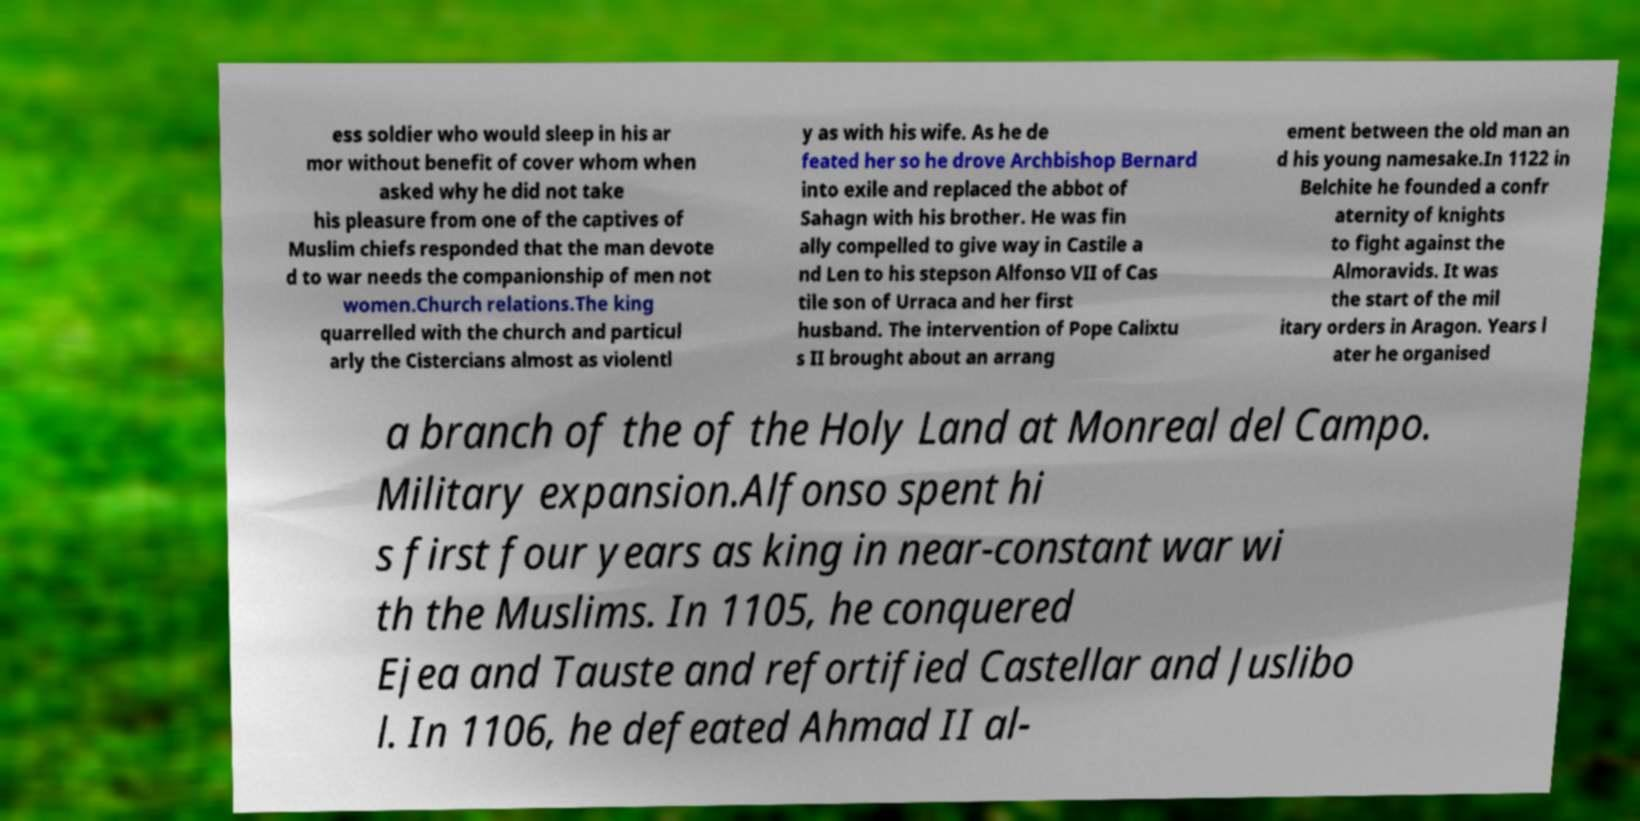I need the written content from this picture converted into text. Can you do that? ess soldier who would sleep in his ar mor without benefit of cover whom when asked why he did not take his pleasure from one of the captives of Muslim chiefs responded that the man devote d to war needs the companionship of men not women.Church relations.The king quarrelled with the church and particul arly the Cistercians almost as violentl y as with his wife. As he de feated her so he drove Archbishop Bernard into exile and replaced the abbot of Sahagn with his brother. He was fin ally compelled to give way in Castile a nd Len to his stepson Alfonso VII of Cas tile son of Urraca and her first husband. The intervention of Pope Calixtu s II brought about an arrang ement between the old man an d his young namesake.In 1122 in Belchite he founded a confr aternity of knights to fight against the Almoravids. It was the start of the mil itary orders in Aragon. Years l ater he organised a branch of the of the Holy Land at Monreal del Campo. Military expansion.Alfonso spent hi s first four years as king in near-constant war wi th the Muslims. In 1105, he conquered Ejea and Tauste and refortified Castellar and Juslibo l. In 1106, he defeated Ahmad II al- 